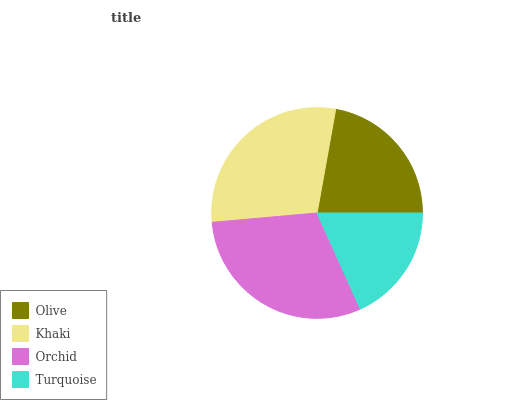Is Turquoise the minimum?
Answer yes or no. Yes. Is Orchid the maximum?
Answer yes or no. Yes. Is Khaki the minimum?
Answer yes or no. No. Is Khaki the maximum?
Answer yes or no. No. Is Khaki greater than Olive?
Answer yes or no. Yes. Is Olive less than Khaki?
Answer yes or no. Yes. Is Olive greater than Khaki?
Answer yes or no. No. Is Khaki less than Olive?
Answer yes or no. No. Is Khaki the high median?
Answer yes or no. Yes. Is Olive the low median?
Answer yes or no. Yes. Is Turquoise the high median?
Answer yes or no. No. Is Orchid the low median?
Answer yes or no. No. 